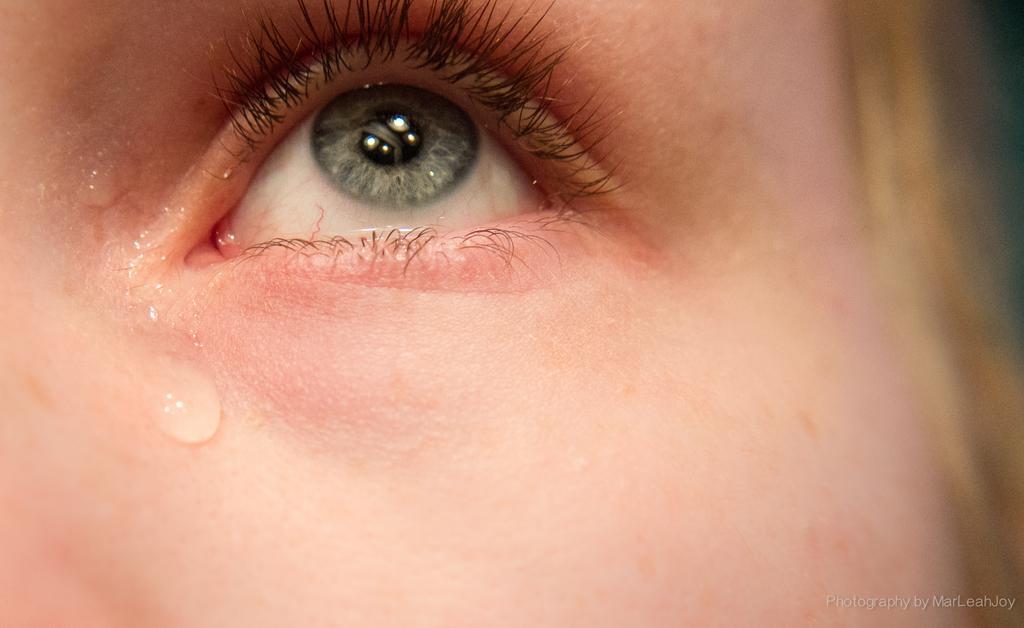How would you summarize this image in a sentence or two? In this image I can see the eye of a person. I can see water on the face. 